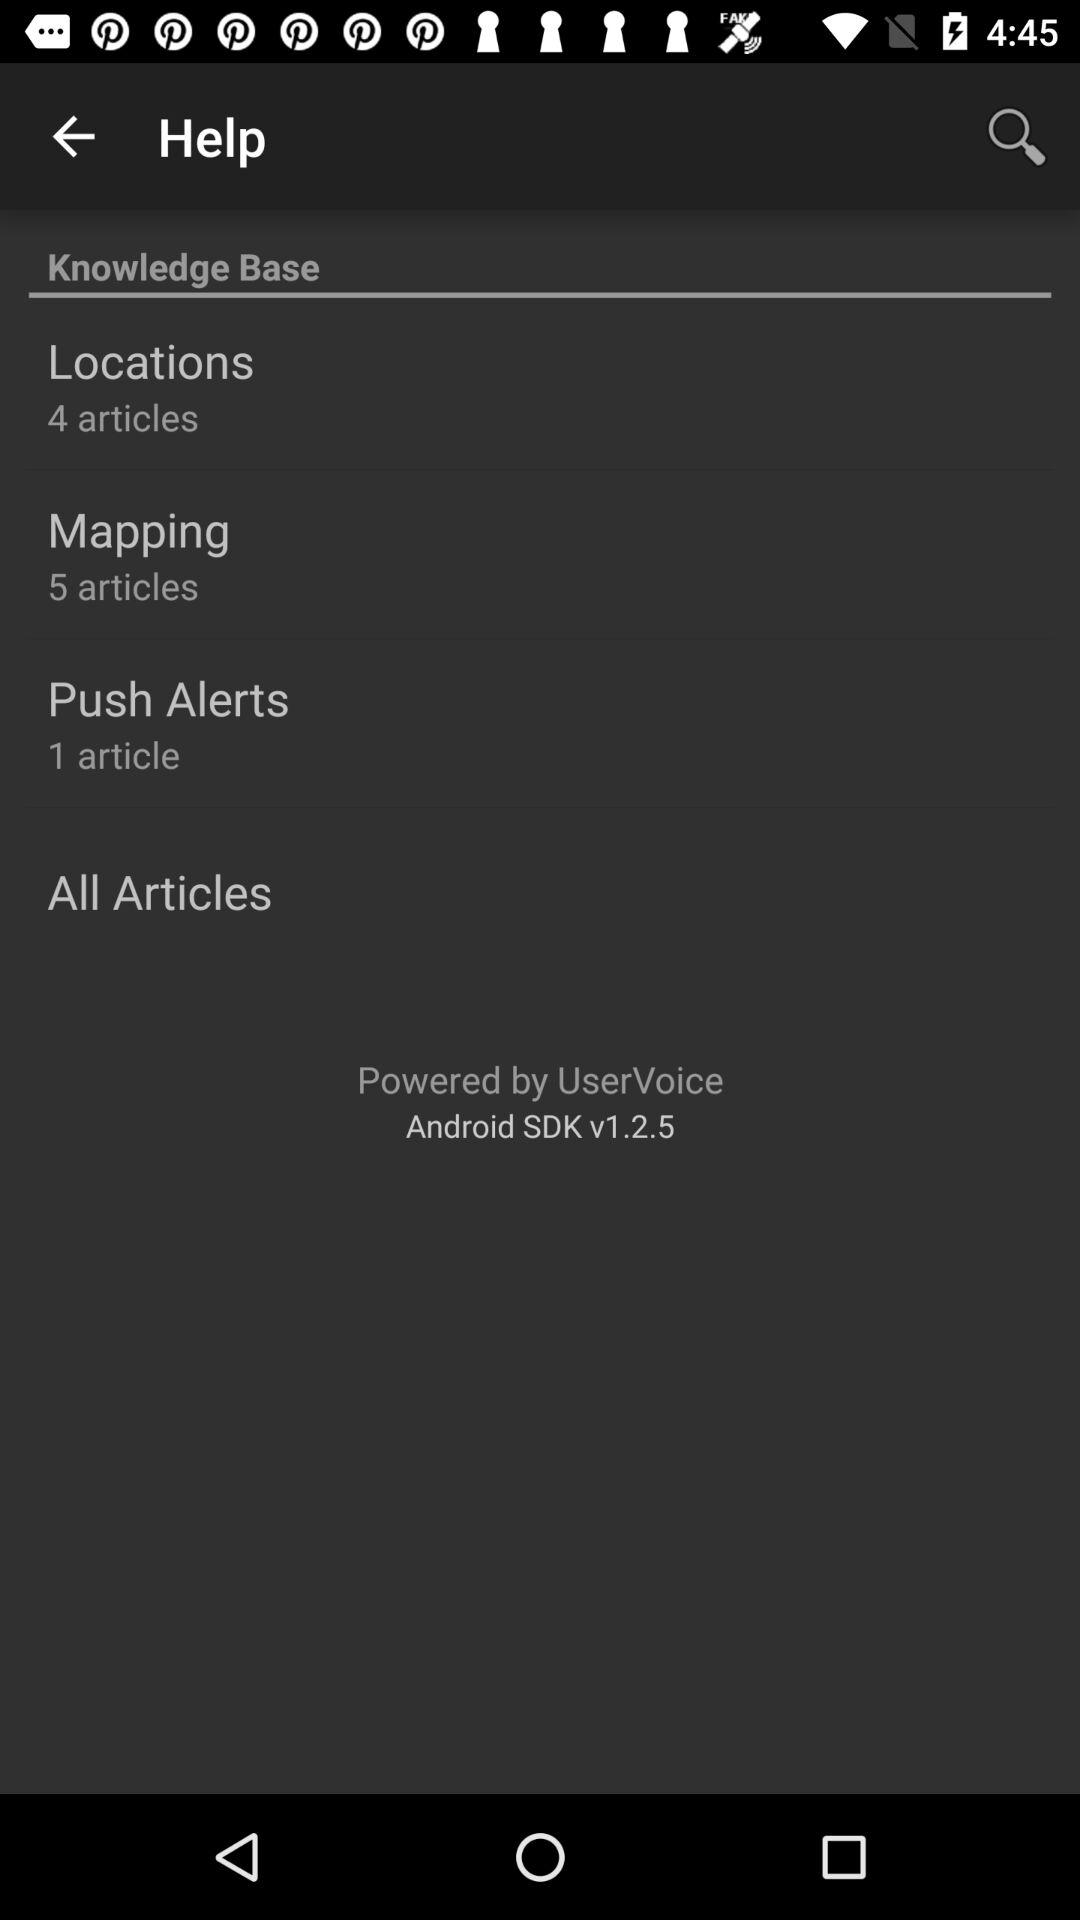How many articles are there in total in the knowledge base?
Answer the question using a single word or phrase. 10 